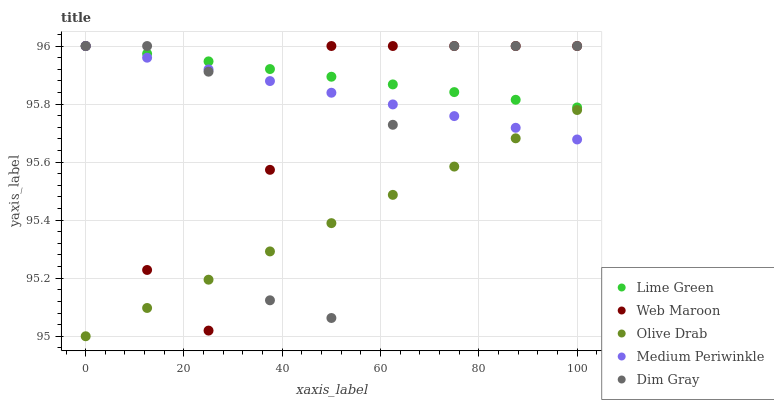Does Olive Drab have the minimum area under the curve?
Answer yes or no. Yes. Does Lime Green have the maximum area under the curve?
Answer yes or no. Yes. Does Dim Gray have the minimum area under the curve?
Answer yes or no. No. Does Dim Gray have the maximum area under the curve?
Answer yes or no. No. Is Medium Periwinkle the smoothest?
Answer yes or no. Yes. Is Dim Gray the roughest?
Answer yes or no. Yes. Is Lime Green the smoothest?
Answer yes or no. No. Is Lime Green the roughest?
Answer yes or no. No. Does Olive Drab have the lowest value?
Answer yes or no. Yes. Does Dim Gray have the lowest value?
Answer yes or no. No. Does Medium Periwinkle have the highest value?
Answer yes or no. Yes. Does Olive Drab have the highest value?
Answer yes or no. No. Is Olive Drab less than Lime Green?
Answer yes or no. Yes. Is Lime Green greater than Olive Drab?
Answer yes or no. Yes. Does Lime Green intersect Dim Gray?
Answer yes or no. Yes. Is Lime Green less than Dim Gray?
Answer yes or no. No. Is Lime Green greater than Dim Gray?
Answer yes or no. No. Does Olive Drab intersect Lime Green?
Answer yes or no. No. 